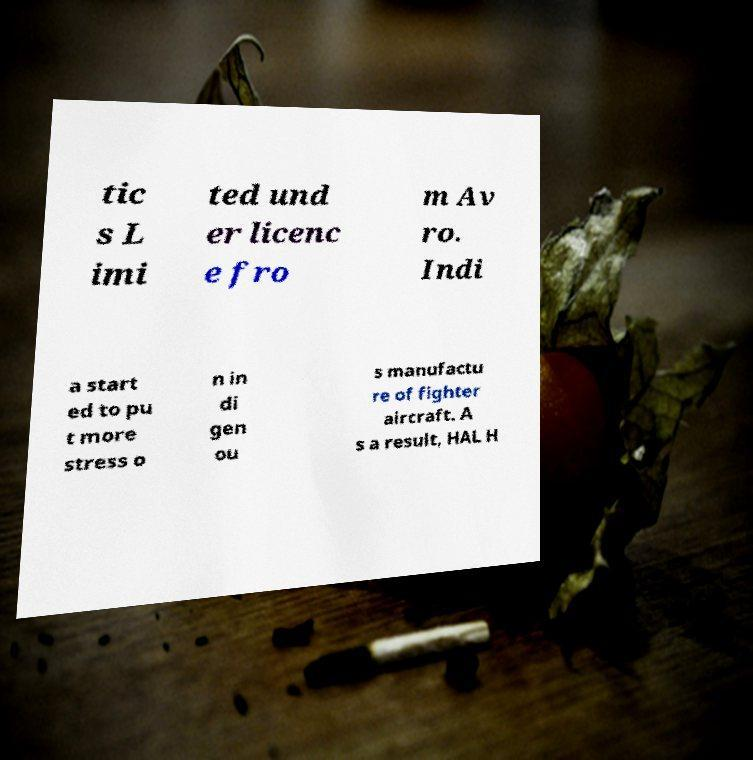Can you accurately transcribe the text from the provided image for me? tic s L imi ted und er licenc e fro m Av ro. Indi a start ed to pu t more stress o n in di gen ou s manufactu re of fighter aircraft. A s a result, HAL H 